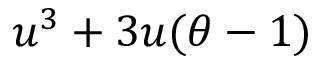<formula> <loc_0><loc_0><loc_500><loc_500>u ^ { 3 } + 3 u ( \theta - 1 )</formula> 